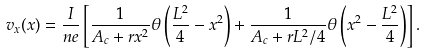Convert formula to latex. <formula><loc_0><loc_0><loc_500><loc_500>v _ { x } ( x ) = \frac { I } { n e } \left [ \frac { 1 } { A _ { c } + r x ^ { 2 } } \theta \left ( \frac { L ^ { 2 } } { 4 } - x ^ { 2 } \right ) + \frac { 1 } { A _ { c } + r L ^ { 2 } / 4 } \theta \left ( x ^ { 2 } - \frac { L ^ { 2 } } { 4 } \right ) \right ] .</formula> 